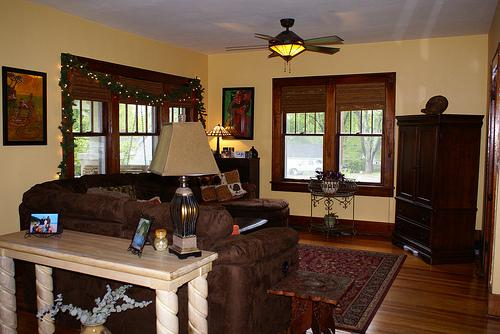Question: who would enjoy this room?
Choices:
A. Nobody.
B. Everyone.
C. Baby.
D. Visitors to the home.
Answer with the letter. Answer: D Question: how is the room kept cool?
Choices:
A. Windows open.
B. A ceiling fan.
C. Fan.
D. Air conditioner.
Answer with the letter. Answer: B Question: where is the picture taken?
Choices:
A. Bathroom.
B. Livingroom.
C. Garage.
D. In a living room.
Answer with the letter. Answer: D Question: what type of decoration is on the wall?
Choices:
A. Wreath.
B. Candle.
C. Sconce.
D. Lights and a Christmas garland.
Answer with the letter. Answer: D Question: why is the floor shiny?
Choices:
A. Wet.
B. Because it was waxed.
C. Because someone spilled juice.
D. Because it is hard wood.
Answer with the letter. Answer: D 